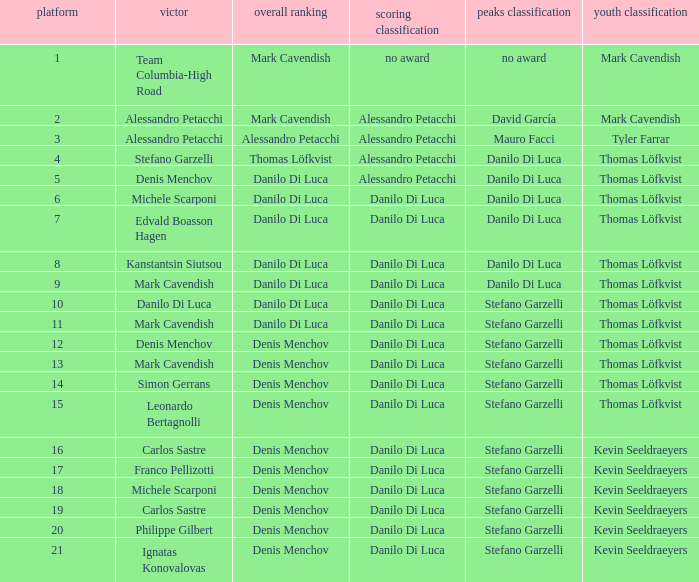With thomas löfkvist as the young rider classification leader and alessandro petacchi dominating the points classification, who occupies the general classifications? Thomas Löfkvist, Danilo Di Luca. Can you parse all the data within this table? {'header': ['platform', 'victor', 'overall ranking', 'scoring classification', 'peaks classification', 'youth classification'], 'rows': [['1', 'Team Columbia-High Road', 'Mark Cavendish', 'no award', 'no award', 'Mark Cavendish'], ['2', 'Alessandro Petacchi', 'Mark Cavendish', 'Alessandro Petacchi', 'David García', 'Mark Cavendish'], ['3', 'Alessandro Petacchi', 'Alessandro Petacchi', 'Alessandro Petacchi', 'Mauro Facci', 'Tyler Farrar'], ['4', 'Stefano Garzelli', 'Thomas Löfkvist', 'Alessandro Petacchi', 'Danilo Di Luca', 'Thomas Löfkvist'], ['5', 'Denis Menchov', 'Danilo Di Luca', 'Alessandro Petacchi', 'Danilo Di Luca', 'Thomas Löfkvist'], ['6', 'Michele Scarponi', 'Danilo Di Luca', 'Danilo Di Luca', 'Danilo Di Luca', 'Thomas Löfkvist'], ['7', 'Edvald Boasson Hagen', 'Danilo Di Luca', 'Danilo Di Luca', 'Danilo Di Luca', 'Thomas Löfkvist'], ['8', 'Kanstantsin Siutsou', 'Danilo Di Luca', 'Danilo Di Luca', 'Danilo Di Luca', 'Thomas Löfkvist'], ['9', 'Mark Cavendish', 'Danilo Di Luca', 'Danilo Di Luca', 'Danilo Di Luca', 'Thomas Löfkvist'], ['10', 'Danilo Di Luca', 'Danilo Di Luca', 'Danilo Di Luca', 'Stefano Garzelli', 'Thomas Löfkvist'], ['11', 'Mark Cavendish', 'Danilo Di Luca', 'Danilo Di Luca', 'Stefano Garzelli', 'Thomas Löfkvist'], ['12', 'Denis Menchov', 'Denis Menchov', 'Danilo Di Luca', 'Stefano Garzelli', 'Thomas Löfkvist'], ['13', 'Mark Cavendish', 'Denis Menchov', 'Danilo Di Luca', 'Stefano Garzelli', 'Thomas Löfkvist'], ['14', 'Simon Gerrans', 'Denis Menchov', 'Danilo Di Luca', 'Stefano Garzelli', 'Thomas Löfkvist'], ['15', 'Leonardo Bertagnolli', 'Denis Menchov', 'Danilo Di Luca', 'Stefano Garzelli', 'Thomas Löfkvist'], ['16', 'Carlos Sastre', 'Denis Menchov', 'Danilo Di Luca', 'Stefano Garzelli', 'Kevin Seeldraeyers'], ['17', 'Franco Pellizotti', 'Denis Menchov', 'Danilo Di Luca', 'Stefano Garzelli', 'Kevin Seeldraeyers'], ['18', 'Michele Scarponi', 'Denis Menchov', 'Danilo Di Luca', 'Stefano Garzelli', 'Kevin Seeldraeyers'], ['19', 'Carlos Sastre', 'Denis Menchov', 'Danilo Di Luca', 'Stefano Garzelli', 'Kevin Seeldraeyers'], ['20', 'Philippe Gilbert', 'Denis Menchov', 'Danilo Di Luca', 'Stefano Garzelli', 'Kevin Seeldraeyers'], ['21', 'Ignatas Konovalovas', 'Denis Menchov', 'Danilo Di Luca', 'Stefano Garzelli', 'Kevin Seeldraeyers']]} 